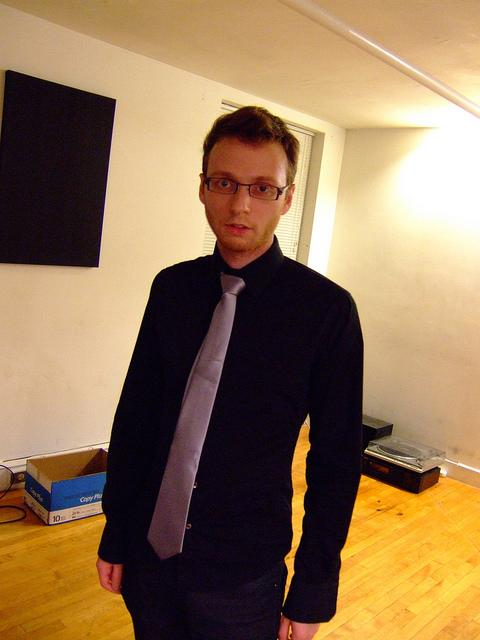What might explain the lack of furniture here? Please explain your reasoning. he's moving. The man is moving. 